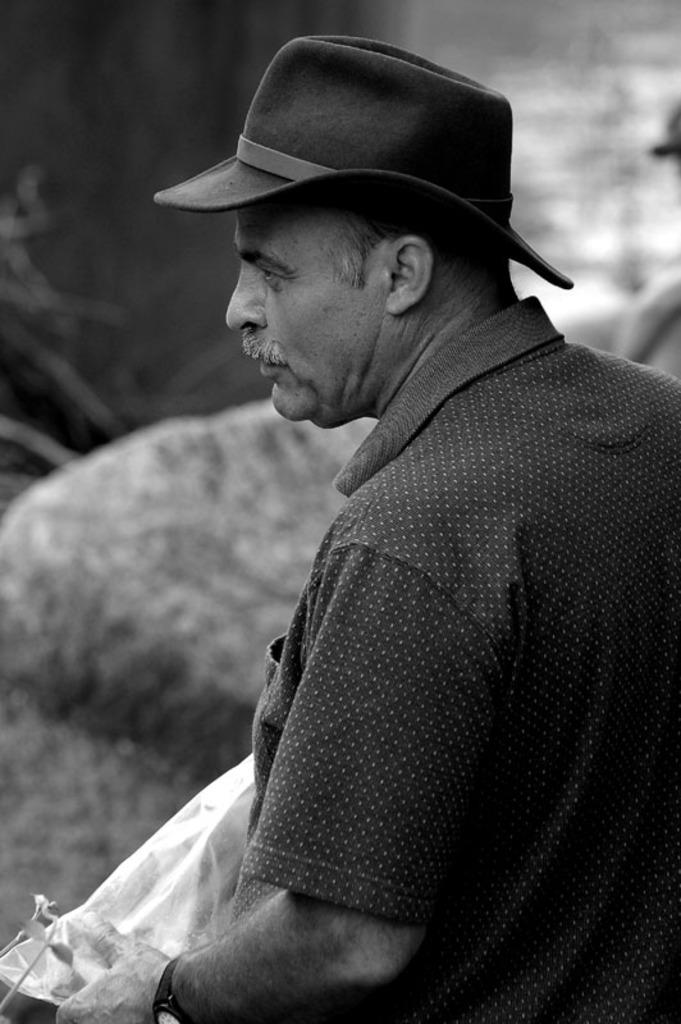Who is present in the image? There is a man in the image. What is the man wearing on his head? The man is wearing a cap. What object can be seen in the image besides the man? There is a rock in the image. How would you describe the background of the image? The background of the image is blurry. What color scheme is used in the image? The image is black and white. What type of scissors is the boy using to cut the giraffe's hair in the image? There is no boy, giraffe, or scissors present in the image. 